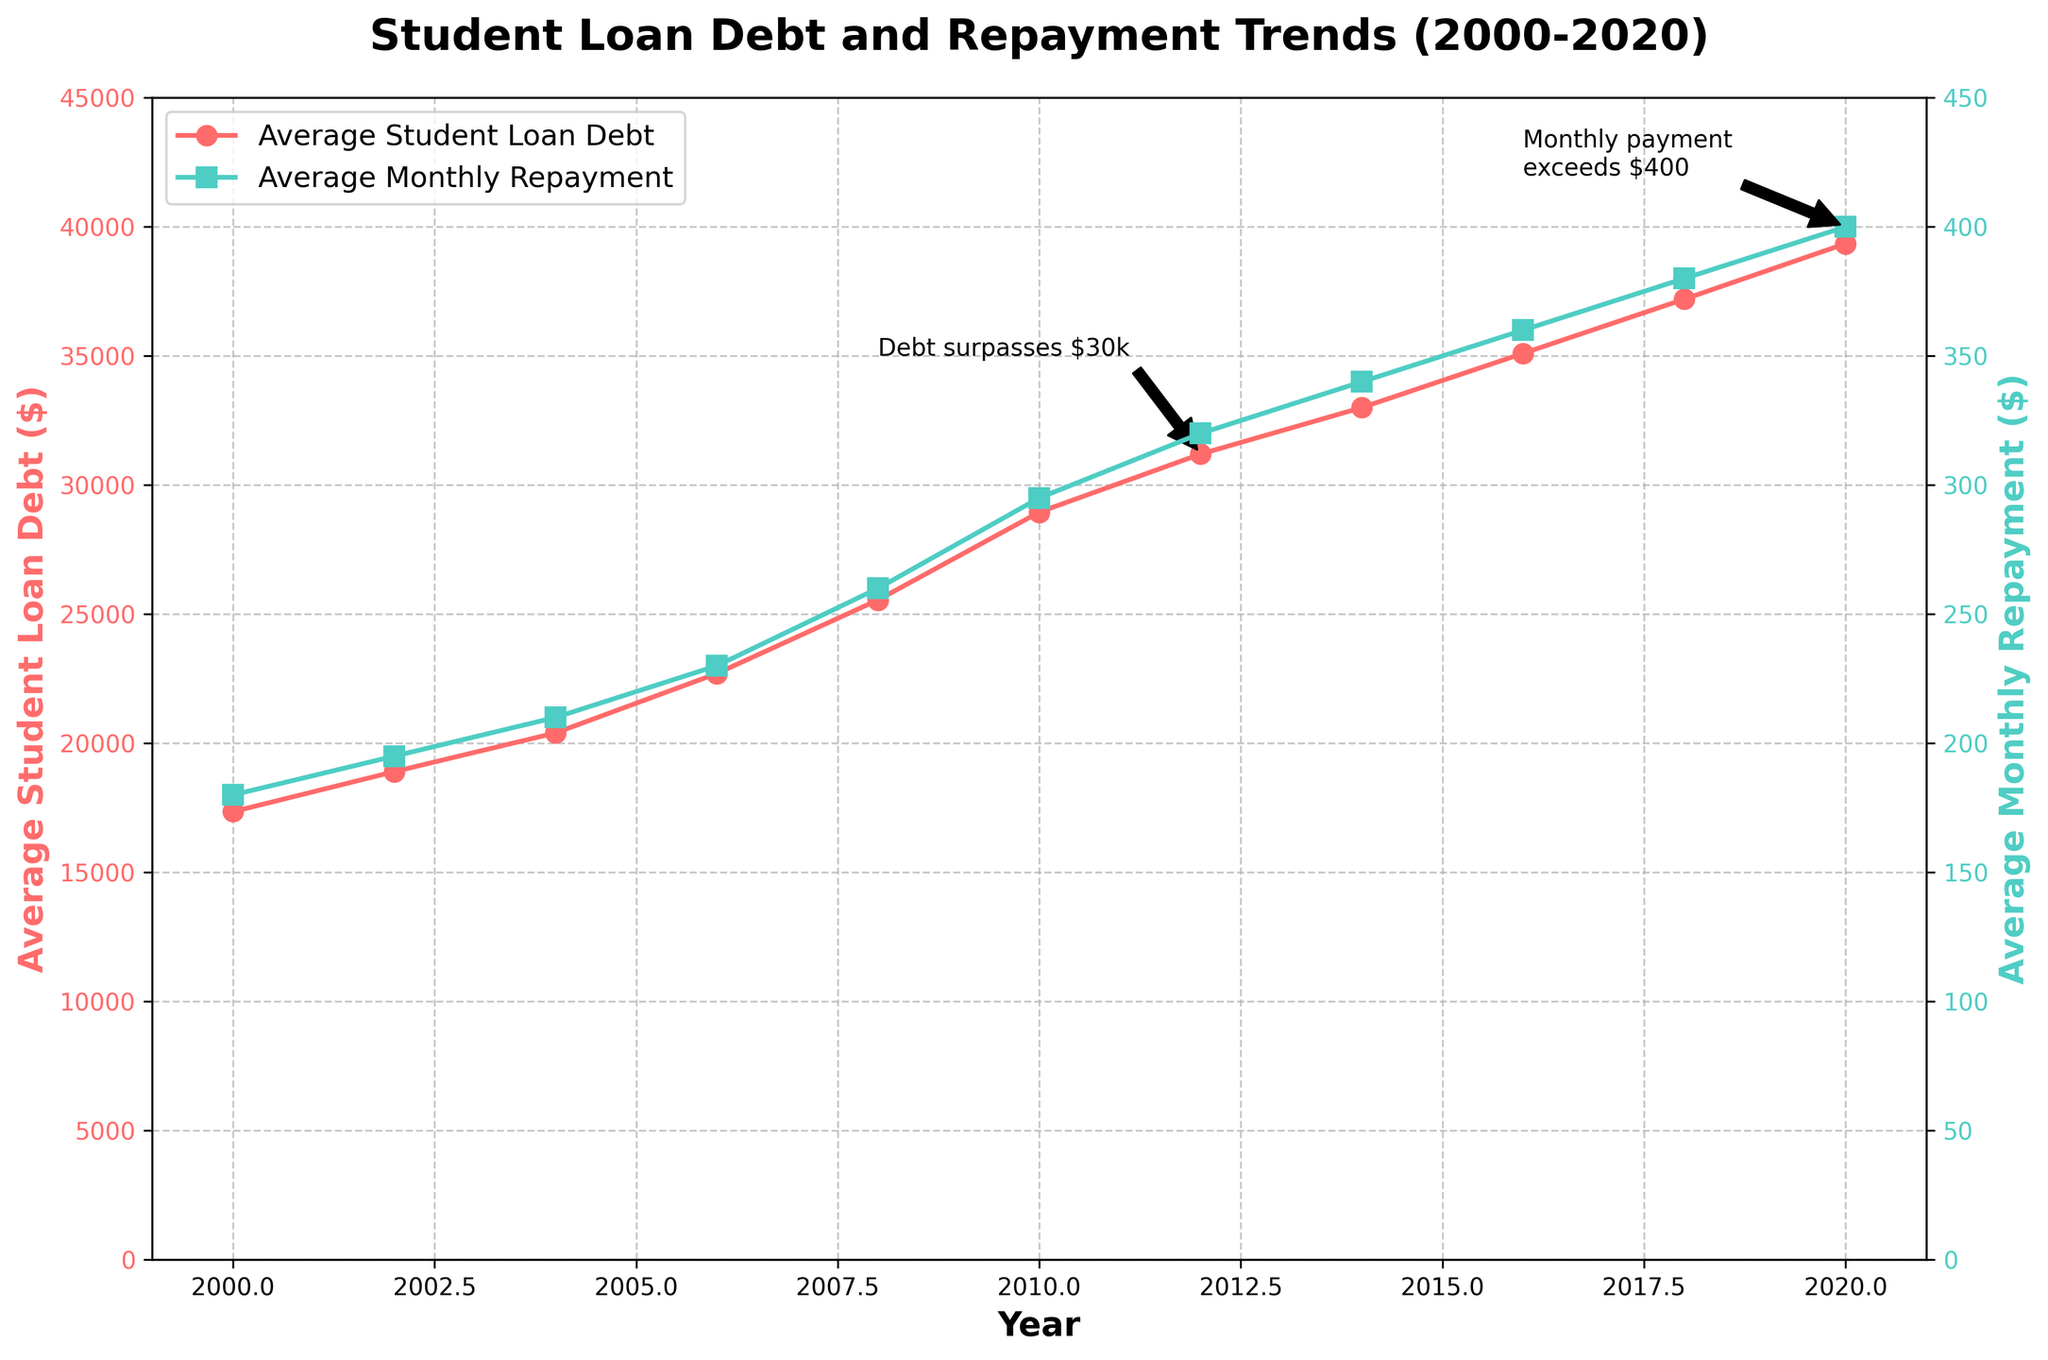What's the average student loan debt in 2010? The figure shows average student loan debt over the years. For 2010, the value is directly annotated on the line chart.
Answer: $28,950 How did the average monthly repayment change from 2000 to 2020? The average monthly repayment in 2000 was $180, and in 2020 it was $400. The difference is calculated as $400 - $180.
Answer: Increased by $220 What year did the average student loan debt first exceed $30,000? We can see from the line chart that the average student loan debt exceeded $30,000 in 2012. This is also annotated.
Answer: 2012 What's the difference in average time to repay the student loans between 2000 and 2020? In 2000, the average time to repay was 8.5 years, and in 2020 it was 14.5 years. The difference is 14.5 years - 8.5 years.
Answer: 6 years Which year shows the steepest increase in average student loan debt? By observing the slope of the line representing average student loan debt, the steepest increase can be seen between 2008 and 2010.
Answer: Between 2008 and 2010 How do the trends in average student loan debt and average monthly repayment compare? Both trends show a continuous increase from 2000 to 2020. The graphical marks (line with markers) for both plots indicate a similar upward trajectory.
Answer: Similar upward trend What is the relationship between average student loan debt and the percentage of graduates with debt in 2020? The figure shows an increase in average student loan debt, and data on the chart indicates that the percentage of graduates with debt was 80% in 2020.
Answer: High debt corresponds with high percentage Estimate how much the average time to repay increased annually from 2000 to 2020. The average time to repay increased from 8.5 years in 2000 to 14.5 years in 2020. Over 20 years, this is (14.5 - 8.5) / 20.
Answer: 0.3 years per annum 